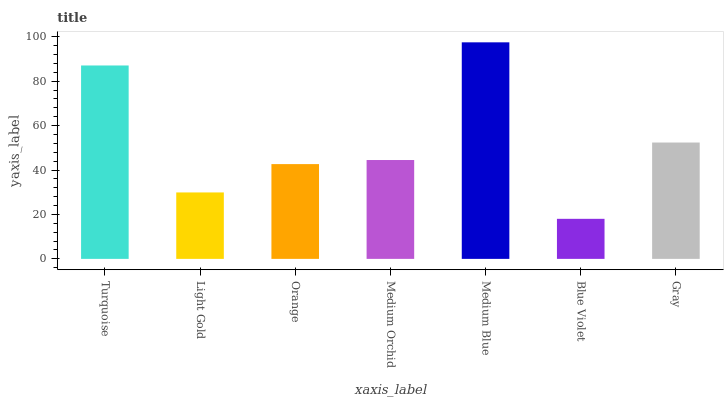Is Light Gold the minimum?
Answer yes or no. No. Is Light Gold the maximum?
Answer yes or no. No. Is Turquoise greater than Light Gold?
Answer yes or no. Yes. Is Light Gold less than Turquoise?
Answer yes or no. Yes. Is Light Gold greater than Turquoise?
Answer yes or no. No. Is Turquoise less than Light Gold?
Answer yes or no. No. Is Medium Orchid the high median?
Answer yes or no. Yes. Is Medium Orchid the low median?
Answer yes or no. Yes. Is Orange the high median?
Answer yes or no. No. Is Turquoise the low median?
Answer yes or no. No. 